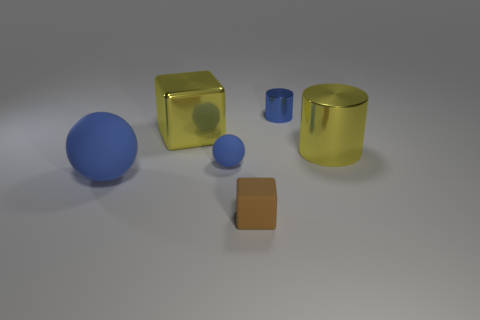There is a blue sphere that is on the left side of the blue sphere behind the large blue matte sphere; how big is it?
Provide a succinct answer. Large. Does the small object behind the yellow metallic cylinder have the same color as the tiny rubber ball?
Your answer should be compact. Yes. Are there any other big blue things that have the same shape as the big blue thing?
Provide a short and direct response. No. There is a metal thing that is the same size as the metallic cube; what is its color?
Your answer should be compact. Yellow. There is a metal object that is on the left side of the tiny brown matte block; what size is it?
Give a very brief answer. Large. Is there a tiny brown object behind the large metallic thing that is on the right side of the small blue metallic cylinder?
Offer a terse response. No. Do the tiny thing that is to the left of the small matte block and the large yellow block have the same material?
Ensure brevity in your answer.  No. How many small objects are both in front of the large blue rubber sphere and behind the big yellow cylinder?
Make the answer very short. 0. What number of cubes have the same material as the big ball?
Provide a short and direct response. 1. What is the color of the tiny ball that is made of the same material as the brown object?
Make the answer very short. Blue. 